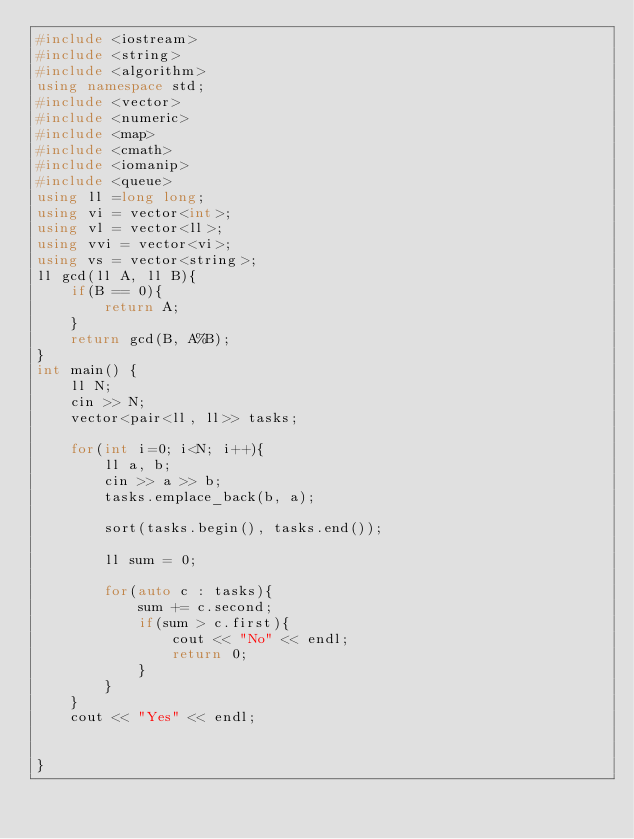<code> <loc_0><loc_0><loc_500><loc_500><_C++_>#include <iostream>
#include <string>
#include <algorithm>
using namespace std;
#include <vector>
#include <numeric>
#include <map>
#include <cmath>
#include <iomanip>
#include <queue>
using ll =long long;
using vi = vector<int>;
using vl = vector<ll>;
using vvi = vector<vi>;
using vs = vector<string>;
ll gcd(ll A, ll B){
    if(B == 0){
        return A;
    }
    return gcd(B, A%B);
}
int main() {
    ll N;
    cin >> N;
    vector<pair<ll, ll>> tasks;

    for(int i=0; i<N; i++){
        ll a, b;
        cin >> a >> b;
        tasks.emplace_back(b, a);

        sort(tasks.begin(), tasks.end());

        ll sum = 0;

        for(auto c : tasks){
            sum += c.second;
            if(sum > c.first){
                cout << "No" << endl;
                return 0;
            }
        }
    }
    cout << "Yes" << endl;


}
</code> 